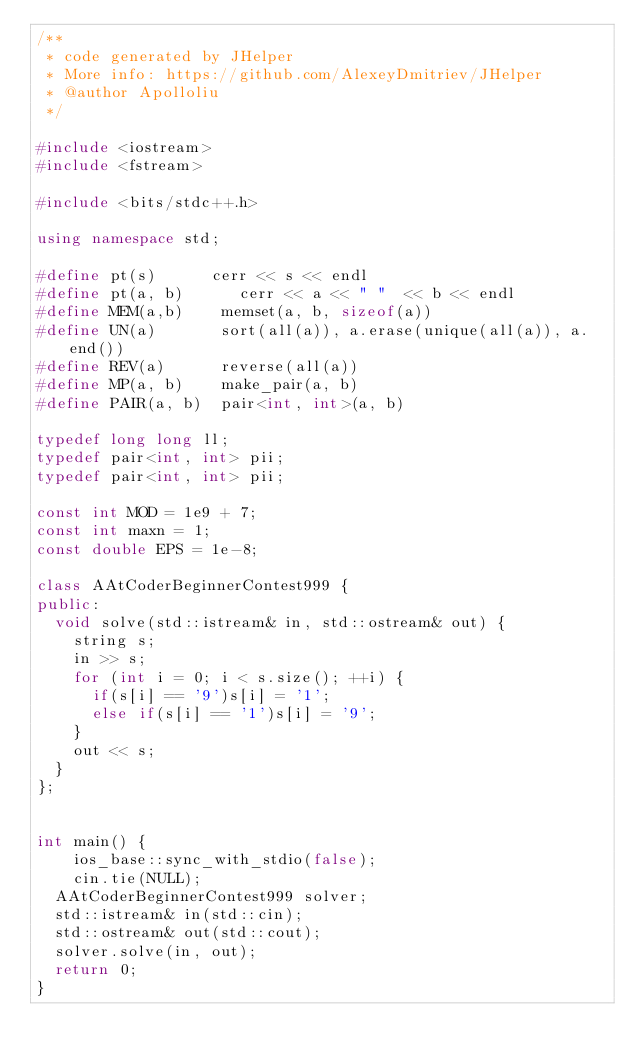Convert code to text. <code><loc_0><loc_0><loc_500><loc_500><_C++_>/**
 * code generated by JHelper
 * More info: https://github.com/AlexeyDmitriev/JHelper
 * @author Apolloliu
 */

#include <iostream>
#include <fstream>

#include <bits/stdc++.h>

using namespace std;

#define pt(s)      cerr << s << endl
#define pt(a, b)      cerr << a << " "  << b << endl
#define MEM(a,b)    memset(a, b, sizeof(a))
#define UN(a)       sort(all(a)), a.erase(unique(all(a)), a.end())
#define REV(a)      reverse(all(a))
#define MP(a, b)    make_pair(a, b)
#define PAIR(a, b)  pair<int, int>(a, b)

typedef long long ll;
typedef pair<int, int> pii;
typedef pair<int, int> pii;

const int MOD = 1e9 + 7;
const int maxn = 1;
const double EPS = 1e-8;

class AAtCoderBeginnerContest999 {
public:
	void solve(std::istream& in, std::ostream& out) {
		string s;
		in >> s;
		for (int i = 0; i < s.size(); ++i) {
			if(s[i] == '9')s[i] = '1';
			else if(s[i] == '1')s[i] = '9';
		}
		out << s;
	}
};


int main() {
    ios_base::sync_with_stdio(false);
    cin.tie(NULL);
	AAtCoderBeginnerContest999 solver;
	std::istream& in(std::cin);
	std::ostream& out(std::cout);
	solver.solve(in, out);
	return 0;
}</code> 